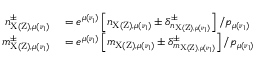<formula> <loc_0><loc_0><loc_500><loc_500>\begin{array} { r l } { n _ { X ( Z ) , \mu ( \nu _ { 1 } ) } ^ { \pm } } & = e ^ { \mu ( \nu _ { 1 } ) } \left [ n _ { X ( Z ) , \mu ( \nu _ { 1 } ) } \pm \delta _ { n _ { X ( Z ) , \mu ( \nu _ { 1 } ) } } ^ { \pm } \right ] / p _ { \mu ( \nu _ { 1 } ) } } \\ { m _ { X ( Z ) , \mu ( \nu _ { 1 } ) } ^ { \pm } } & = e ^ { \mu ( \nu _ { 1 } ) } \left [ m _ { X ( Z ) , \mu ( \nu _ { 1 } ) } \pm \delta _ { m _ { X ( Z ) , \mu ( \nu _ { 1 } ) } } ^ { \pm } \right ] / p _ { \mu ( \nu _ { 1 } ) } } \end{array}</formula> 